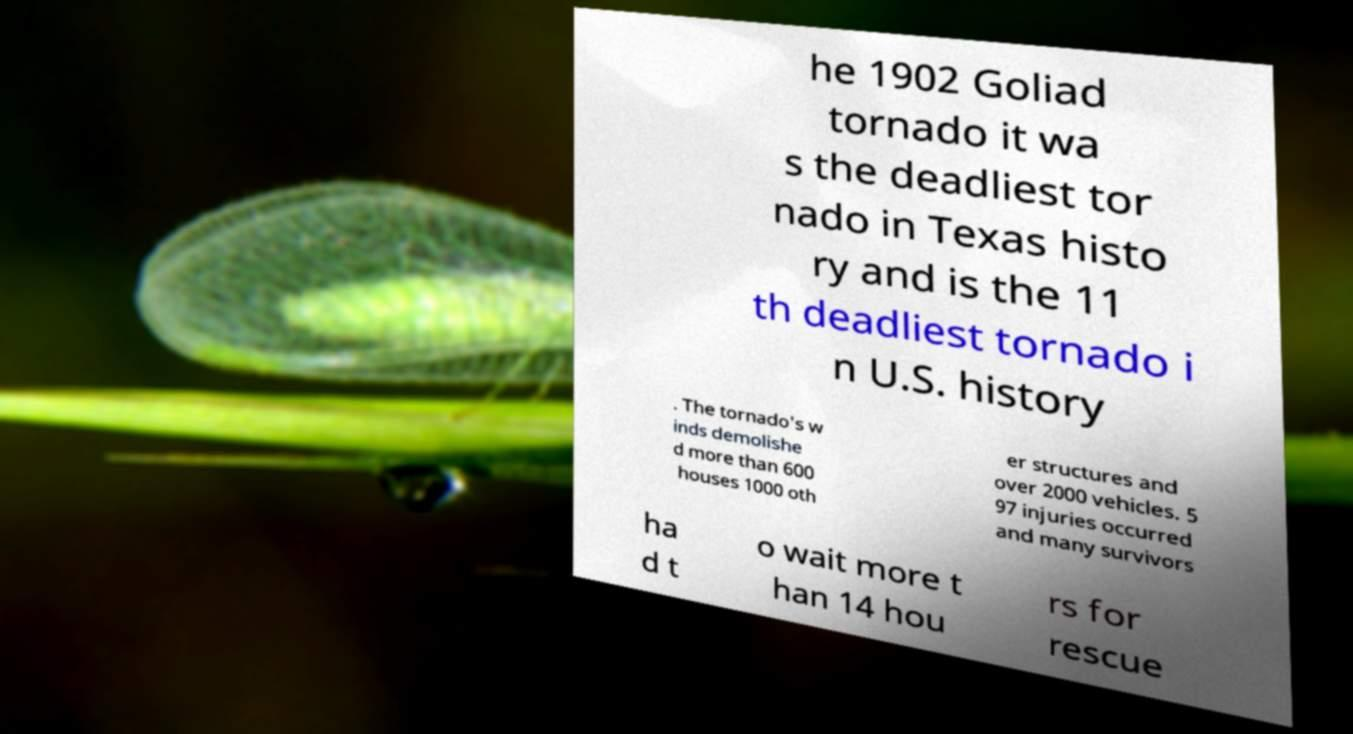Could you assist in decoding the text presented in this image and type it out clearly? he 1902 Goliad tornado it wa s the deadliest tor nado in Texas histo ry and is the 11 th deadliest tornado i n U.S. history . The tornado's w inds demolishe d more than 600 houses 1000 oth er structures and over 2000 vehicles. 5 97 injuries occurred and many survivors ha d t o wait more t han 14 hou rs for rescue 